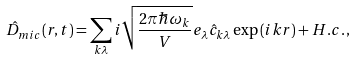<formula> <loc_0><loc_0><loc_500><loc_500>\hat { D } _ { m i c } ( { r } , t ) = \sum _ { { k } \lambda } i \sqrt { \frac { 2 \pi \hbar { \omega } _ { k } } { V } } { e } _ { \lambda } \hat { c } _ { { k } \lambda } \exp \left ( i { k } { r } \right ) + H . c . \, ,</formula> 